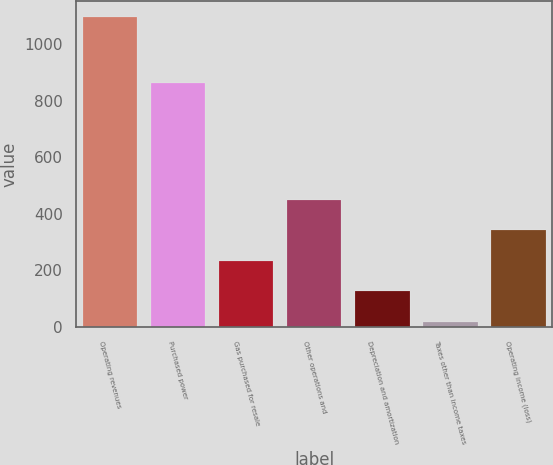Convert chart to OTSL. <chart><loc_0><loc_0><loc_500><loc_500><bar_chart><fcel>Operating revenues<fcel>Purchased power<fcel>Gas purchased for resale<fcel>Other operations and<fcel>Depreciation and amortization<fcel>Taxes other than income taxes<fcel>Operating income (loss)<nl><fcel>1096<fcel>861<fcel>232.8<fcel>448.6<fcel>124.9<fcel>17<fcel>340.7<nl></chart> 